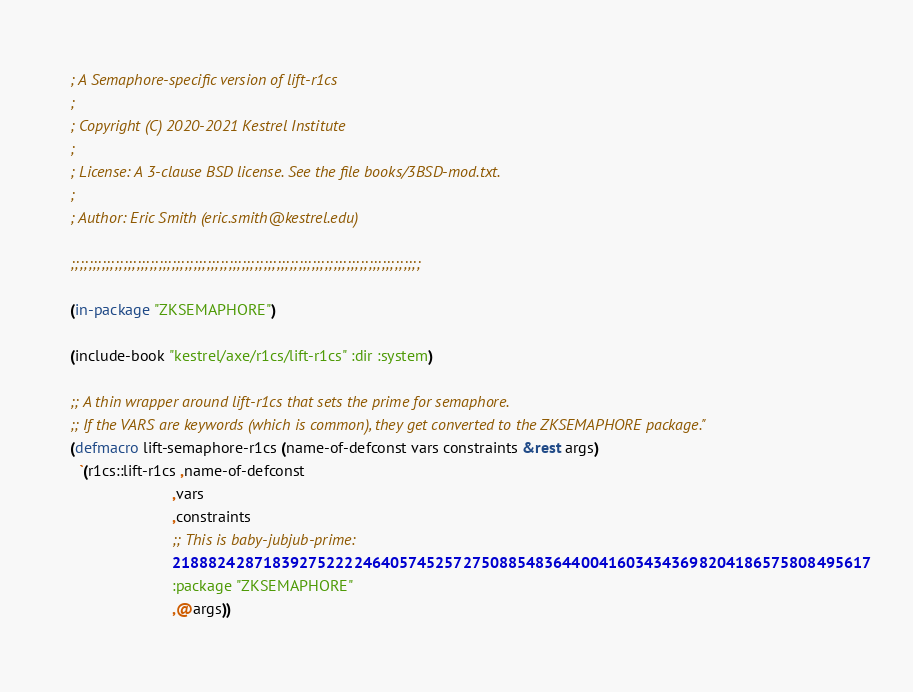Convert code to text. <code><loc_0><loc_0><loc_500><loc_500><_Lisp_>; A Semaphore-specific version of lift-r1cs
;
; Copyright (C) 2020-2021 Kestrel Institute
;
; License: A 3-clause BSD license. See the file books/3BSD-mod.txt.
;
; Author: Eric Smith (eric.smith@kestrel.edu)

;;;;;;;;;;;;;;;;;;;;;;;;;;;;;;;;;;;;;;;;;;;;;;;;;;;;;;;;;;;;;;;;;;;;;;;;;;;;;;;;

(in-package "ZKSEMAPHORE")

(include-book "kestrel/axe/r1cs/lift-r1cs" :dir :system)

;; A thin wrapper around lift-r1cs that sets the prime for semaphore.
;; If the VARS are keywords (which is common), they get converted to the ZKSEMAPHORE package."
(defmacro lift-semaphore-r1cs (name-of-defconst vars constraints &rest args)
  `(r1cs::lift-r1cs ,name-of-defconst
                        ,vars
                        ,constraints
                        ;; This is baby-jubjub-prime:
                        21888242871839275222246405745257275088548364400416034343698204186575808495617
                        :package "ZKSEMAPHORE"
                        ,@args))
</code> 